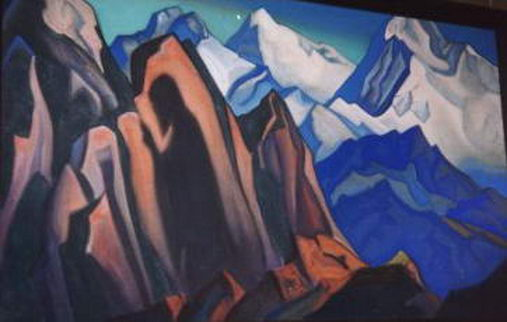What emotions do you think this image evokes? The image likely evokes a range of emotions, from awe and wonder due to the majestic portrayal of the mountains, to a sense of tranquility and peace as a result of the serene sky and harmonious color palette. The use of cubist elements could also stimulate curiosity and intrigue, inviting the viewer to explore the deeper layers of the artwork. 